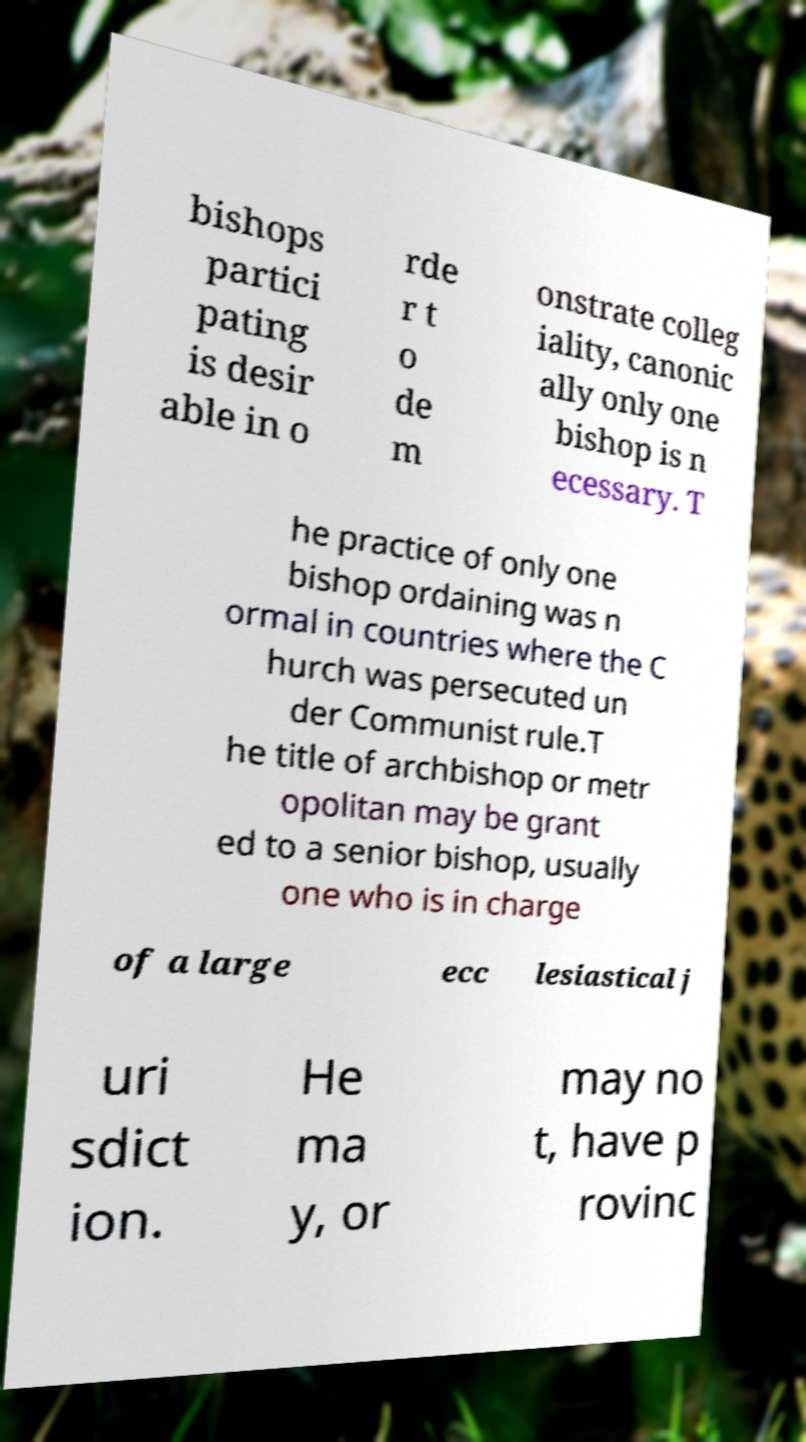Could you assist in decoding the text presented in this image and type it out clearly? bishops partici pating is desir able in o rde r t o de m onstrate colleg iality, canonic ally only one bishop is n ecessary. T he practice of only one bishop ordaining was n ormal in countries where the C hurch was persecuted un der Communist rule.T he title of archbishop or metr opolitan may be grant ed to a senior bishop, usually one who is in charge of a large ecc lesiastical j uri sdict ion. He ma y, or may no t, have p rovinc 